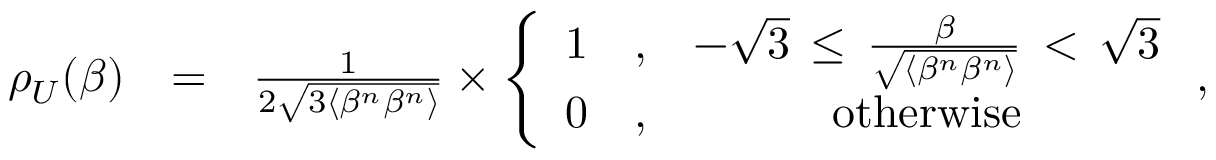Convert formula to latex. <formula><loc_0><loc_0><loc_500><loc_500>\begin{array} { r l r } { \rho _ { U } ( \beta ) } & { = } & { \frac { 1 } { 2 \sqrt { 3 \langle \beta ^ { n } \beta ^ { n } \rangle } } \times \left \{ \begin{array} { c c c } { 1 } & { , } & { - \sqrt { 3 } \, \leq \, \frac { \beta } { \sqrt { \langle \beta ^ { n } \beta ^ { n } \rangle } } \, < \, \sqrt { 3 } } \\ { 0 } & { , } & { o t h e r w i s e } \end{array} , } \end{array}</formula> 